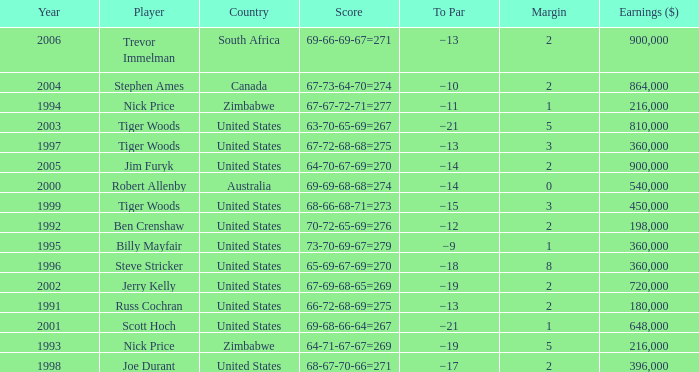Which To Par has Earnings ($) larger than 360,000, and a Year larger than 1998, and a Country of united states, and a Score of 69-68-66-64=267? −21. 